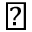<formula> <loc_0><loc_0><loc_500><loc_500>\blacktriangleright</formula> 